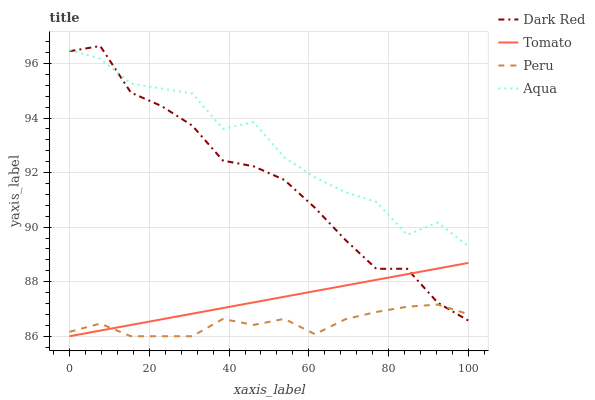Does Peru have the minimum area under the curve?
Answer yes or no. Yes. Does Aqua have the maximum area under the curve?
Answer yes or no. Yes. Does Dark Red have the minimum area under the curve?
Answer yes or no. No. Does Dark Red have the maximum area under the curve?
Answer yes or no. No. Is Tomato the smoothest?
Answer yes or no. Yes. Is Aqua the roughest?
Answer yes or no. Yes. Is Dark Red the smoothest?
Answer yes or no. No. Is Dark Red the roughest?
Answer yes or no. No. Does Tomato have the lowest value?
Answer yes or no. Yes. Does Dark Red have the lowest value?
Answer yes or no. No. Does Dark Red have the highest value?
Answer yes or no. Yes. Does Aqua have the highest value?
Answer yes or no. No. Is Peru less than Aqua?
Answer yes or no. Yes. Is Aqua greater than Peru?
Answer yes or no. Yes. Does Tomato intersect Dark Red?
Answer yes or no. Yes. Is Tomato less than Dark Red?
Answer yes or no. No. Is Tomato greater than Dark Red?
Answer yes or no. No. Does Peru intersect Aqua?
Answer yes or no. No. 